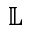<formula> <loc_0><loc_0><loc_500><loc_500>\mathbb { L }</formula> 